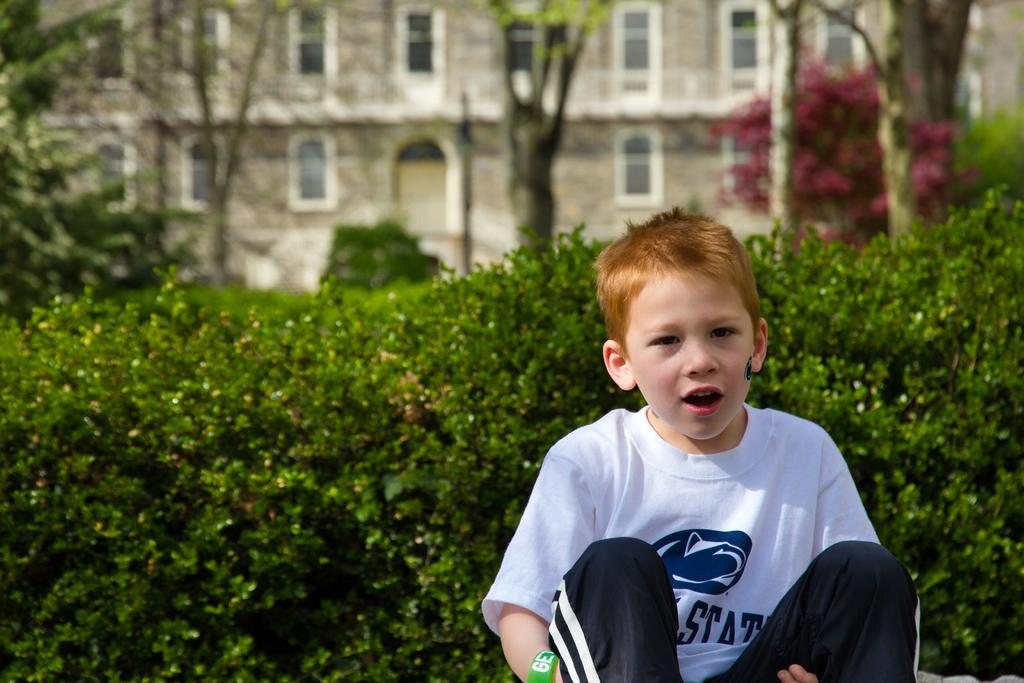<image>
Provide a brief description of the given image. A child with face paint wears a Penn State shirt in front of a bush. 